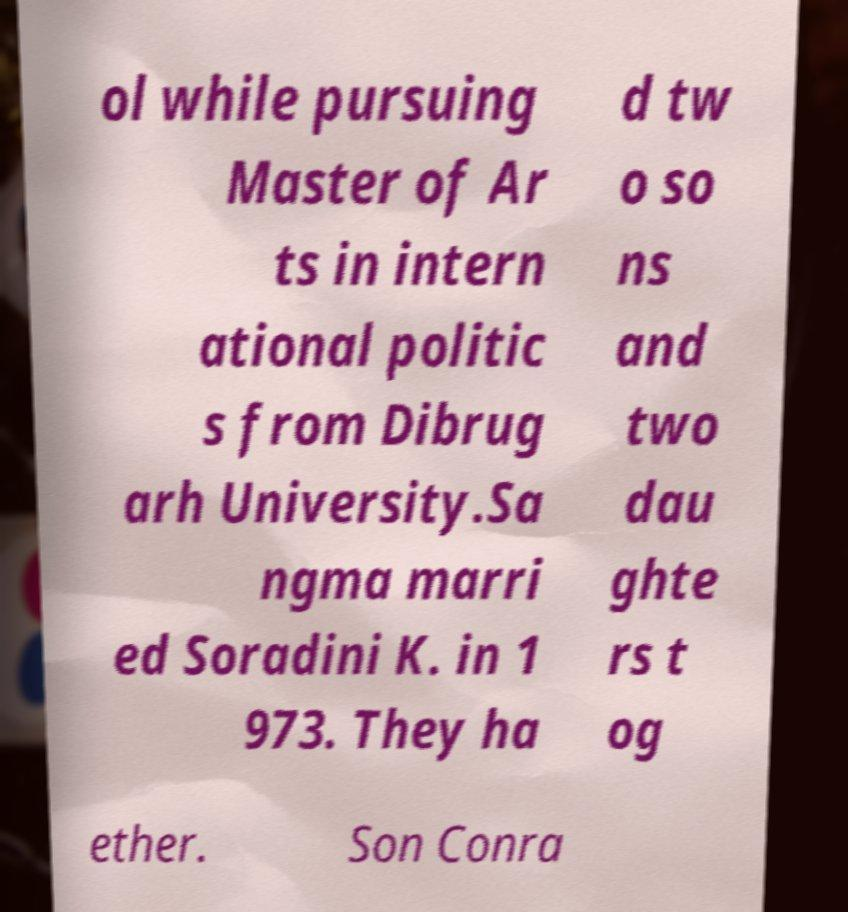Please identify and transcribe the text found in this image. ol while pursuing Master of Ar ts in intern ational politic s from Dibrug arh University.Sa ngma marri ed Soradini K. in 1 973. They ha d tw o so ns and two dau ghte rs t og ether. Son Conra 